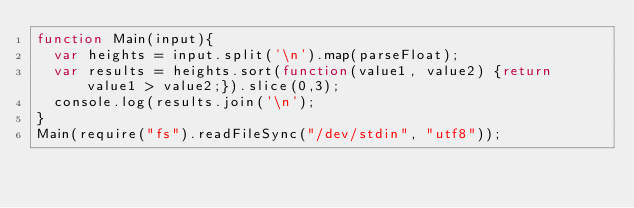<code> <loc_0><loc_0><loc_500><loc_500><_JavaScript_>function Main(input){
  var heights = input.split('\n').map(parseFloat);
  var results = heights.sort(function(value1, value2) {return value1 > value2;}).slice(0,3);
  console.log(results.join('\n');
}
Main(require("fs").readFileSync("/dev/stdin", "utf8"));</code> 